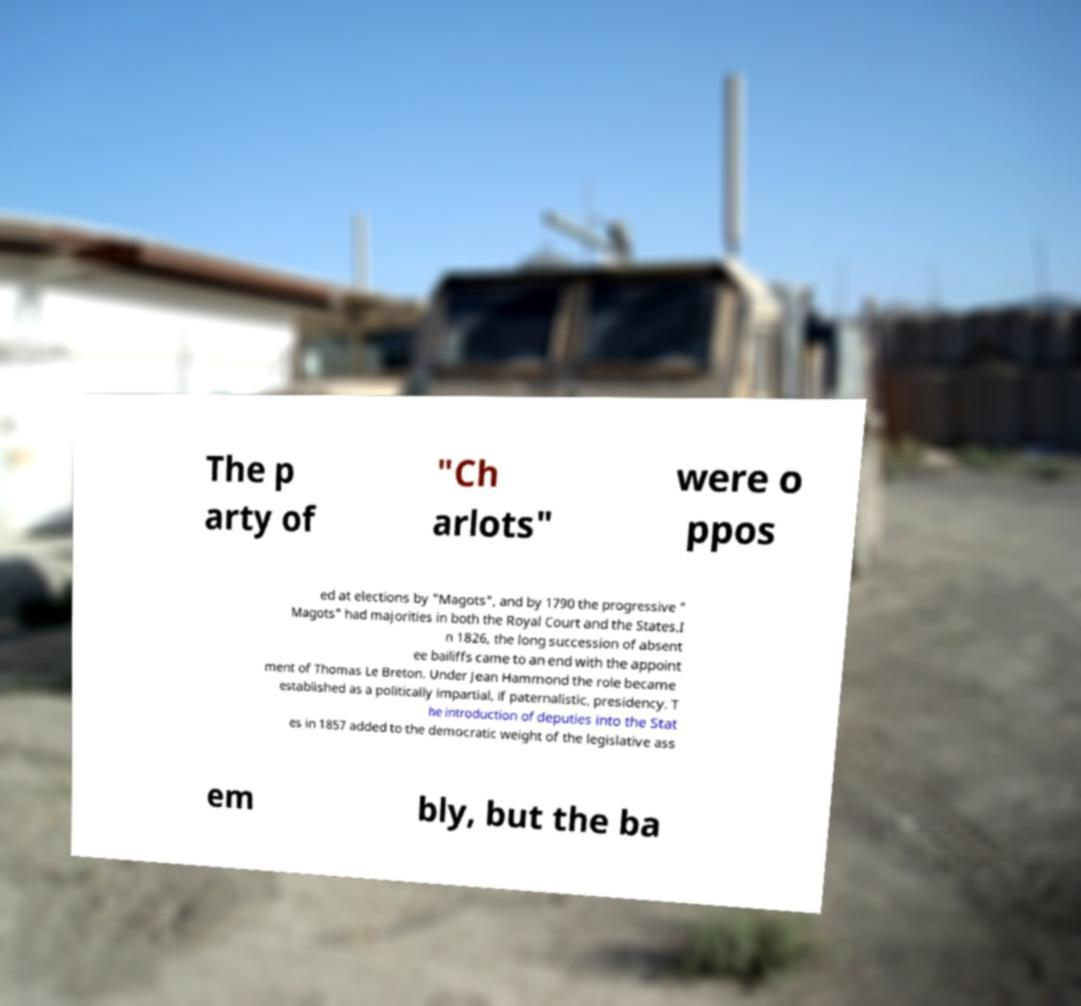Please read and relay the text visible in this image. What does it say? The p arty of "Ch arlots" were o ppos ed at elections by "Magots", and by 1790 the progressive " Magots" had majorities in both the Royal Court and the States.I n 1826, the long succession of absent ee bailiffs came to an end with the appoint ment of Thomas Le Breton. Under Jean Hammond the role became established as a politically impartial, if paternalistic, presidency. T he introduction of deputies into the Stat es in 1857 added to the democratic weight of the legislative ass em bly, but the ba 